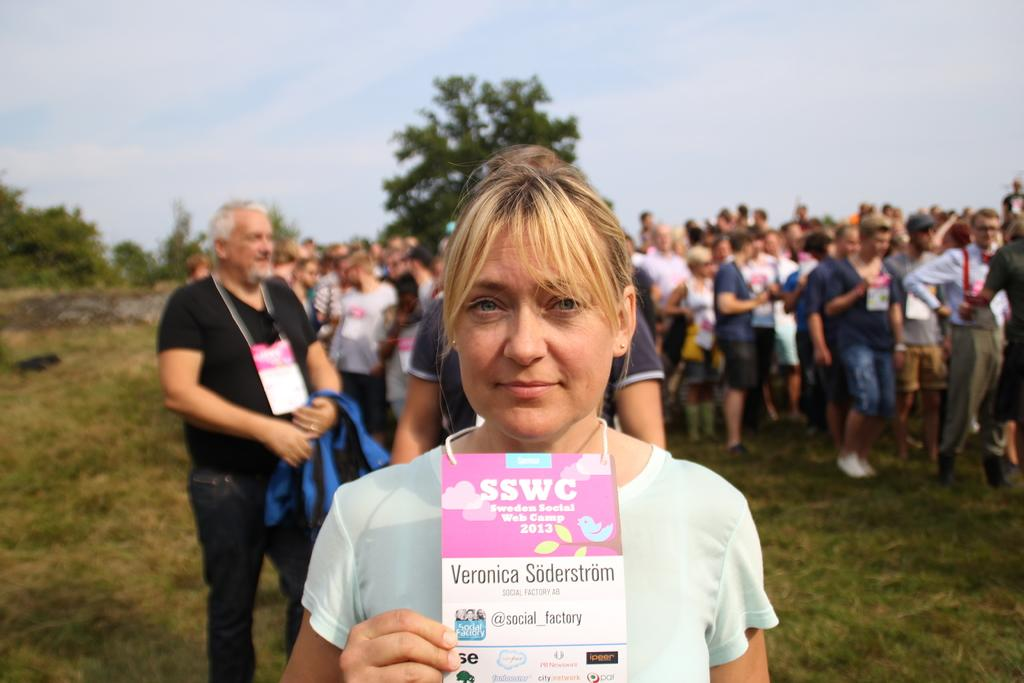How many people are in the image? There are people in the image, but the exact number is not specified. What is the lady holding in the image? The lady is holding an object in the image. What type of surface can be seen under the people's feet? The ground is visible in the image. What type of vegetation is present in the image? There is grass in the image. What else can be seen in the background of the image? There are trees and the sky visible in the image. Can you see a plane flying over the sea in the image? There is no plane or sea present in the image. 